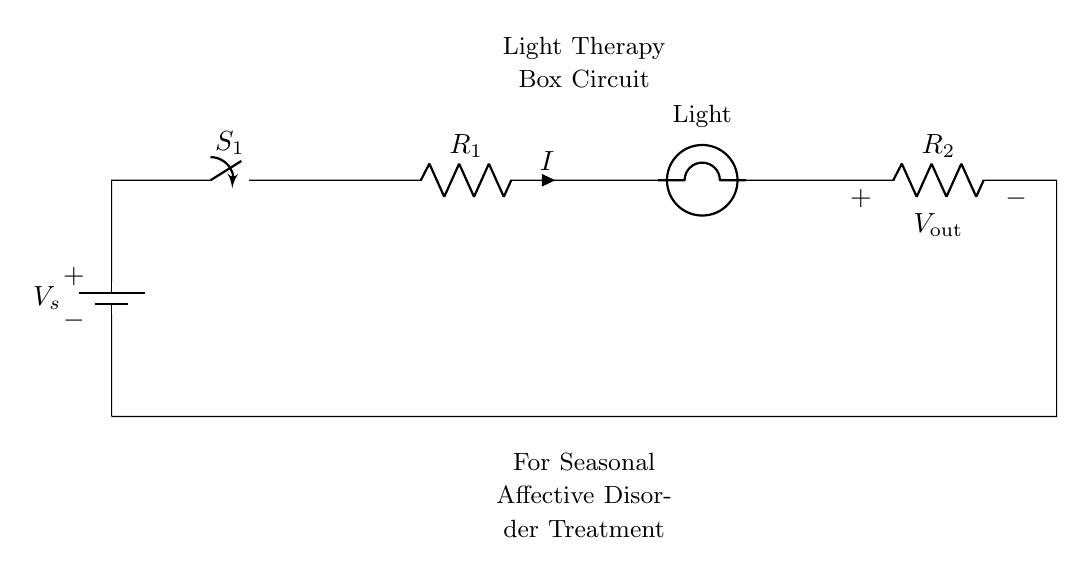What is the source voltage in this circuit? The source voltage is denoted as V_s, which is typically the value provided by the battery.
Answer: V_s What component is used to control the flow of current in this circuit? The component that controls the flow of current in the circuit is a switch, labeled S_1.
Answer: Switch How many resistors are present in the circuit? There are two resistors indicated in the diagram, labeled R_1 and R_2.
Answer: Two What is the function of the bulb in this circuit? The bulb's function is to provide light as part of the light therapy for seasonal affective disorder.
Answer: Provide light What would happen to the current if R_1 is increased? Increasing R_1 would result in a decrease in the current (I) as per Ohm's law since higher resistance limits the flow of current through the circuit.
Answer: Decrease What is the output voltage labeled as in the circuit? The output voltage is identified as V_out, which is the voltage across the second resistor R_2.
Answer: V_out In a series circuit like this, how does the current behave across all components? In a series circuit, the current remains the same through all components, meaning that the same current I flows through the battery, switch, resistors, and the bulb.
Answer: Same current 